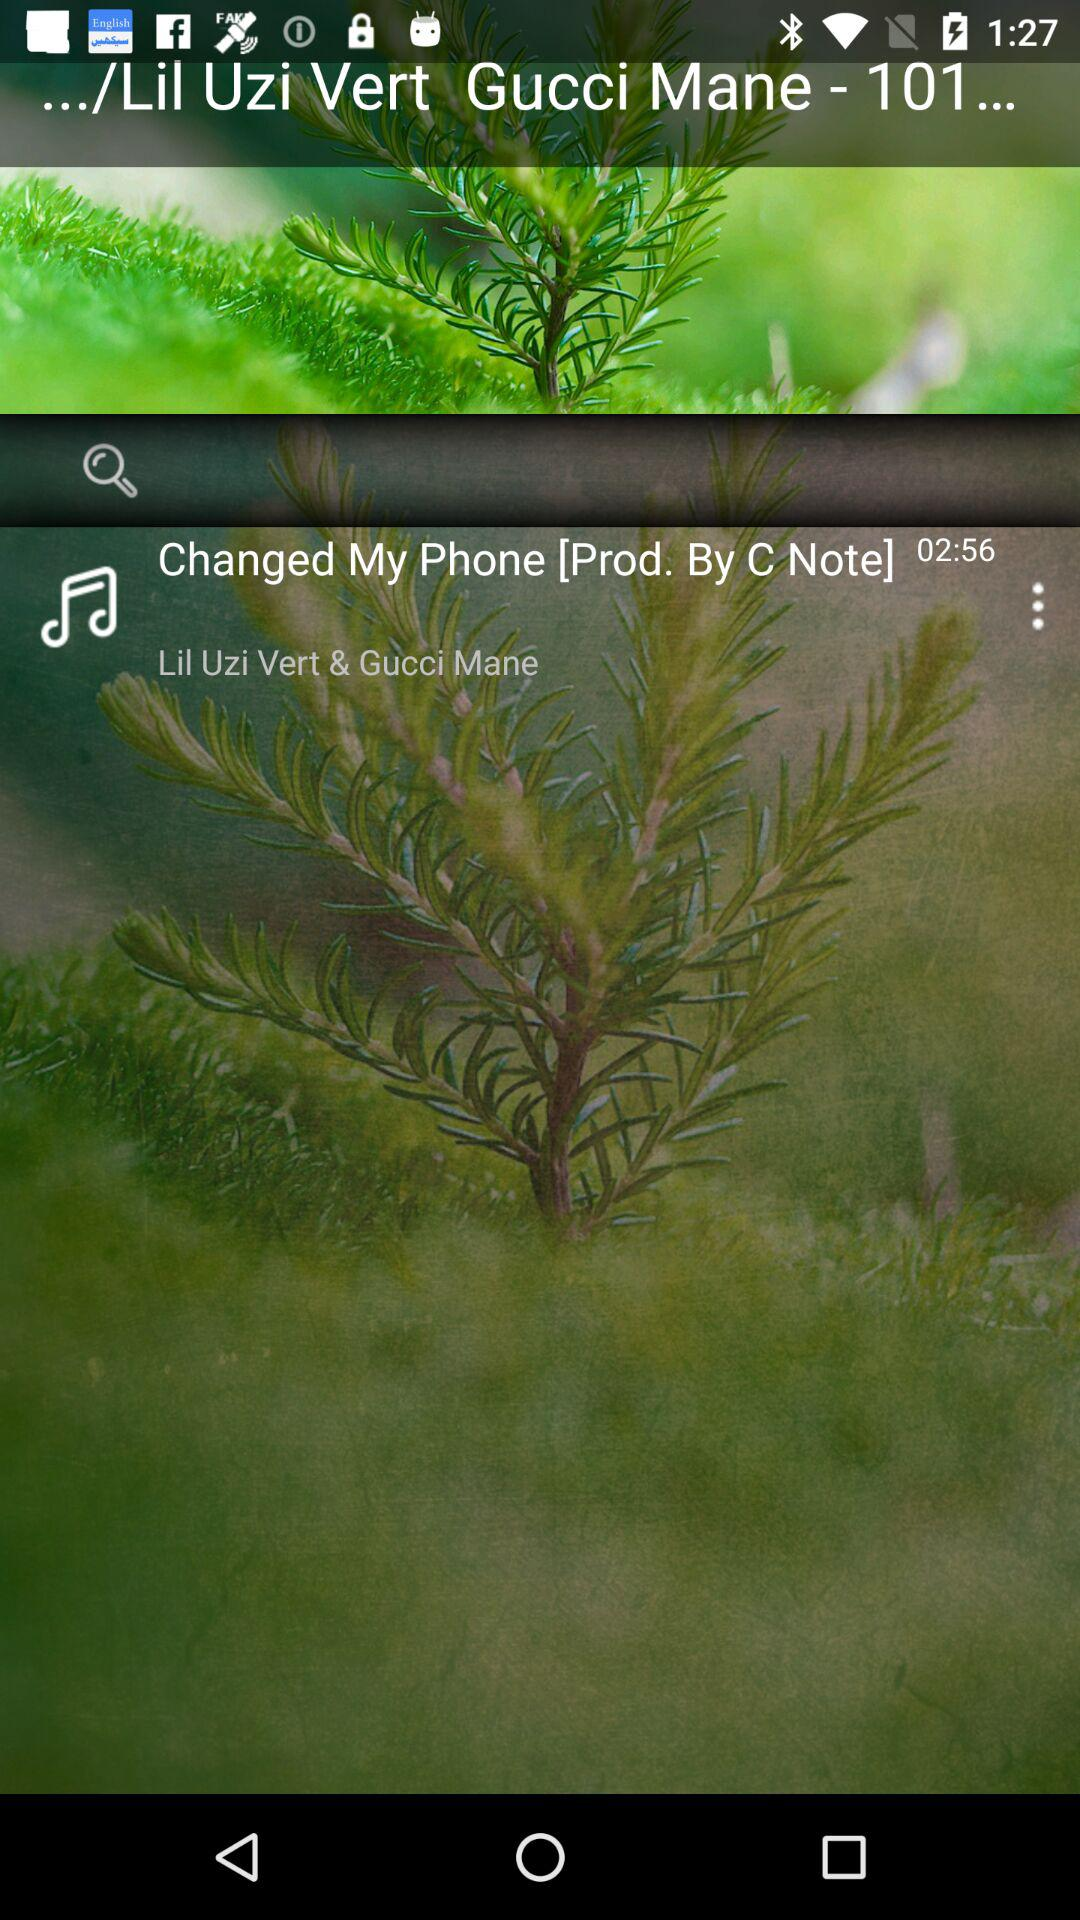What is the name of the song? The name of the song is "Changed My Phone". 